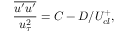Convert formula to latex. <formula><loc_0><loc_0><loc_500><loc_500>\frac { \overline { { u ^ { \prime } u ^ { \prime } } } } { u _ { \tau } ^ { 2 } } = C - D / U _ { c l } ^ { + } ,</formula> 